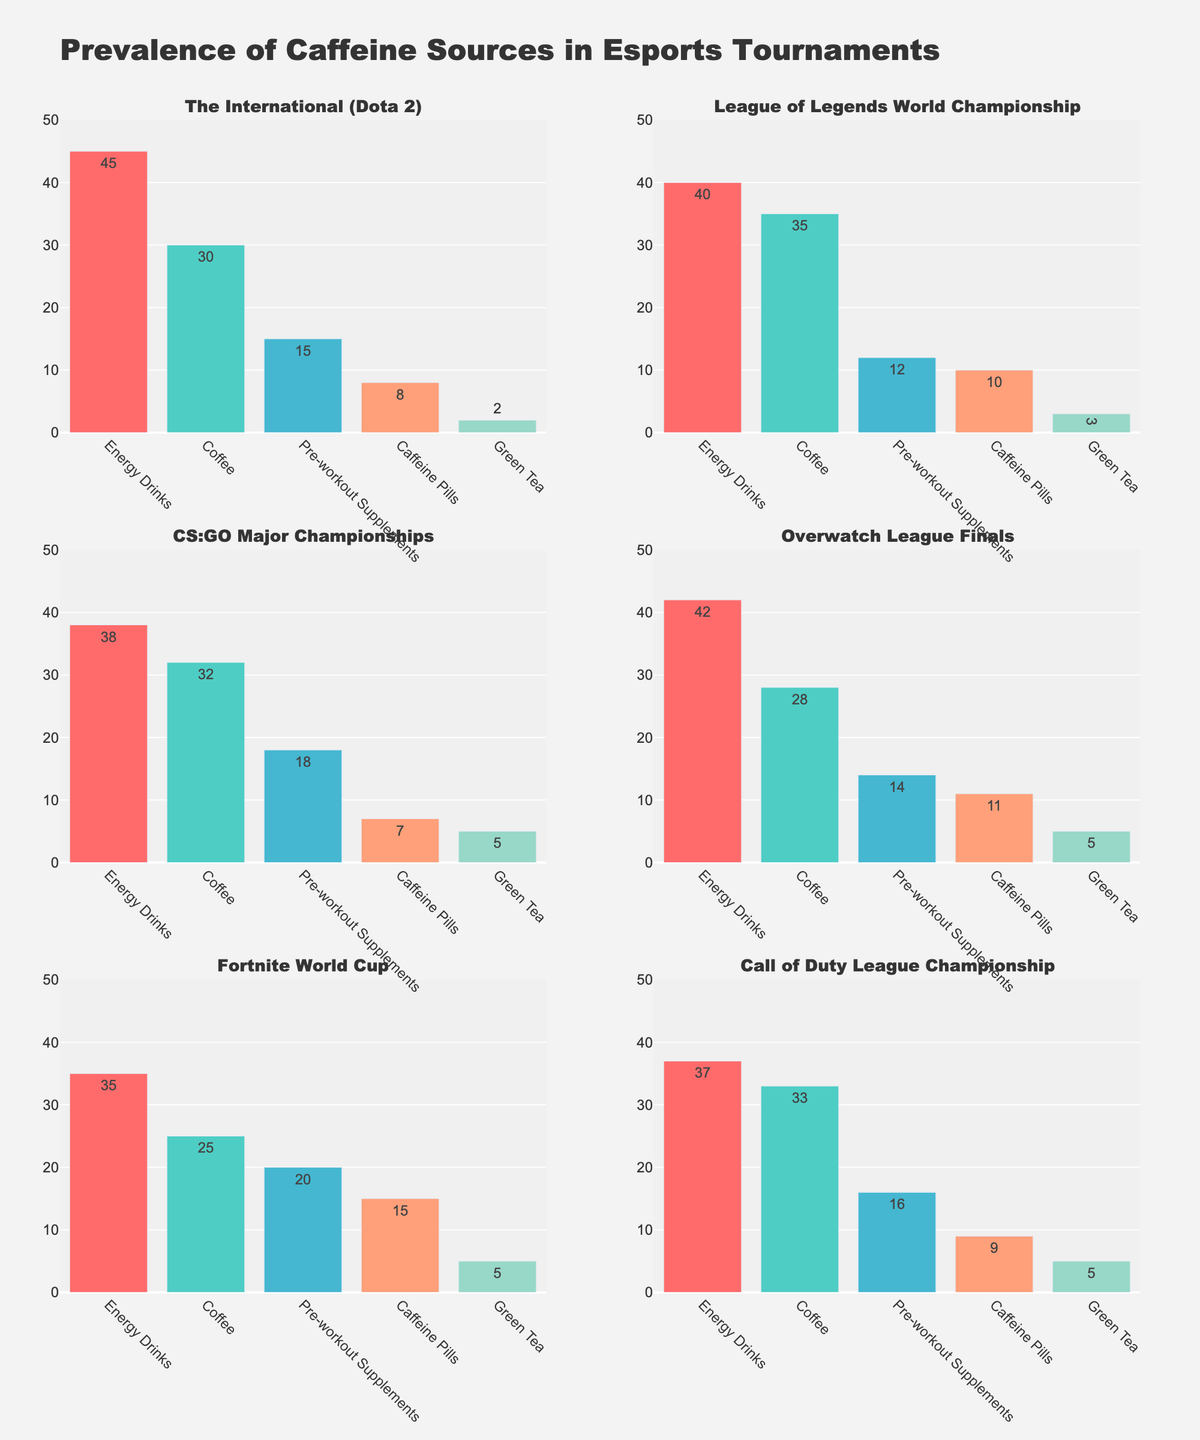What is the title of the figure? The title of the figure is usually found at the top of the plot. Here, it clearly states, "Prevalence of Caffeine Sources in Esports Tournaments."
Answer: Prevalence of Caffeine Sources in Esports Tournaments What is the most common caffeine source used in the League of Legends World Championship? By looking at the subplot for the League of Legends World Championship, the bar with the highest value represents the most common caffeine source. In this case, the "Energy Drinks" bar has the highest value at 40, making it the most common source.
Answer: Energy Drinks Which tournament has the highest prevalence of coffee usage? To determine this, compare the heights of the "Coffee" bars across all six subplots. The League of Legends World Championship shows the highest value for coffee usage at 35.
Answer: League of Legends World Championship How many tournaments have green tea as a caffeine source with more than 2 players? Check the values for Green Tea in each subplot to count how many tournaments have values greater than 2. Here, the tournaments are League of Legends World Championship (3), CS:GO Major Championships (5), Overwatch League Finals (5), Fortnite World Cup (5), and Call of Duty League Championship (5). This makes a total of 5 tournaments.
Answer: 5 What is the average prevalence of caffeine pills across all tournaments? To find the average, sum all the values for "Caffeine Pills" and divide by the number of tournaments: (8+10+7+11+15+9) = 60, and there are 6 tournaments. The average is 60/6 = 10.
Answer: 10 Which caffeine source is used the least in Call of Duty League Championship? Look at the subplot for the Call of Duty League Championship and identify the bar with the smallest value. "Green Tea" has the smallest value at 5, making it the least used caffeine source.
Answer: Green Tea Between Overwatch League Finals and Fortnite World Cup, which tournament has a higher prevalence of pre-workout supplements? Compare the heights of the "Pre-workout Supplements" bars in the two subplots. The Overwatch League Finals have 14, whereas the Fortnite World Cup has 20. So, the Fortnite World Cup has a higher prevalence.
Answer: Fortnite World Cup What is the sum of energy drink usage across all tournaments? Add up the values of "Energy Drinks" from all six subplots: 45 (The International) + 40 (LoL World Championship) + 38 (CS:GO Major) + 42 (Overwatch Finals) + 35 (Fortnite World Cup) + 37 (Call of Duty League) = 237.
Answer: 237 How does the prevalence of caffeine pills compare between The International (Dota 2) and CS:GO Major Championships? Identify the values of "Caffeine Pills" in both subplots. The International has 8, while CS:GO Major Championships have 7. The International has a slightly higher prevalence.
Answer: The International (Dota 2) Which tournament has the overall highest prevalence of any caffeine source and what is it? Scan each subplot to find the highest bar overall. The "Energy Drinks" bar in The International (Dota 2) stands out at 45, making it the highest prevalence of any caffeine source.
Answer: The International (Dota 2), 45 